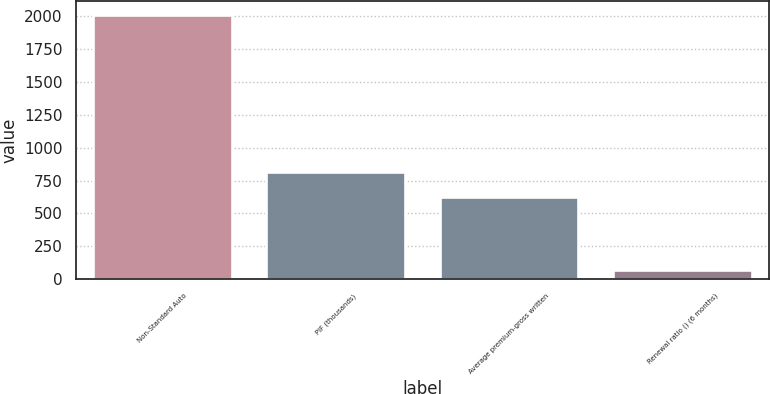<chart> <loc_0><loc_0><loc_500><loc_500><bar_chart><fcel>Non-Standard Auto<fcel>PIF (thousands)<fcel>Average premium-gross written<fcel>Renewal ratio () (6 months)<nl><fcel>2008<fcel>817.43<fcel>624<fcel>73.7<nl></chart> 